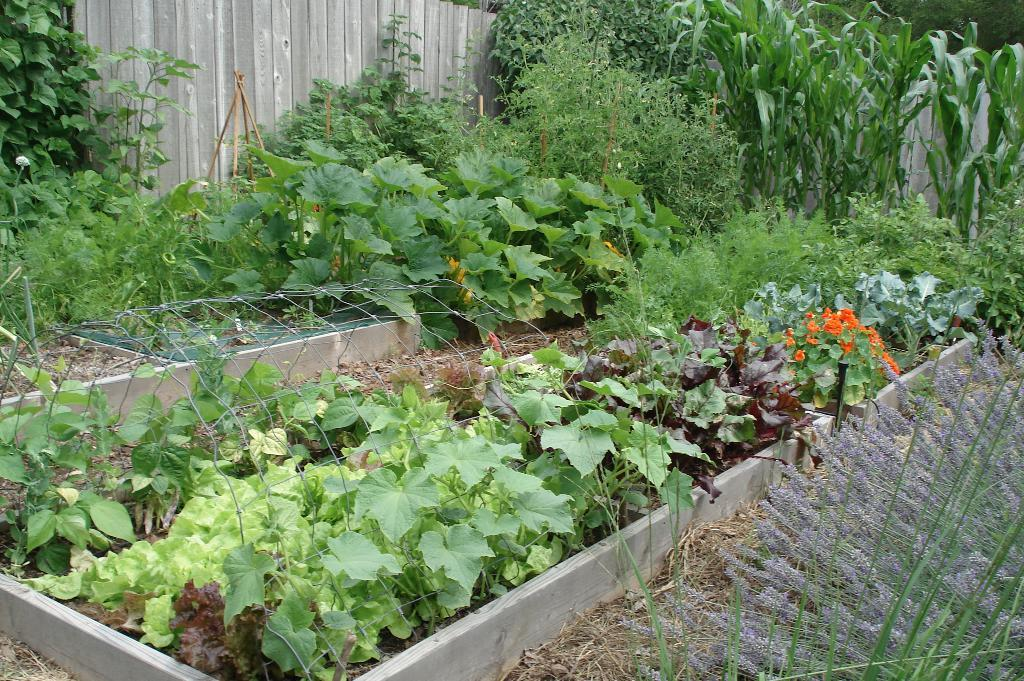What type of vegetation can be seen in the image? There are plants and creepers in the image. What is the structure made of that has mesh in the image? There is a concrete box with mesh in the image. What type of fencing is visible in the background of the image? There is a wooden fencing in the background of the image. What type of garden is being used to express hate in the image? There is no indication of hate or a garden in the image; it features plants, creepers, a concrete box with mesh, and a wooden fencing. 